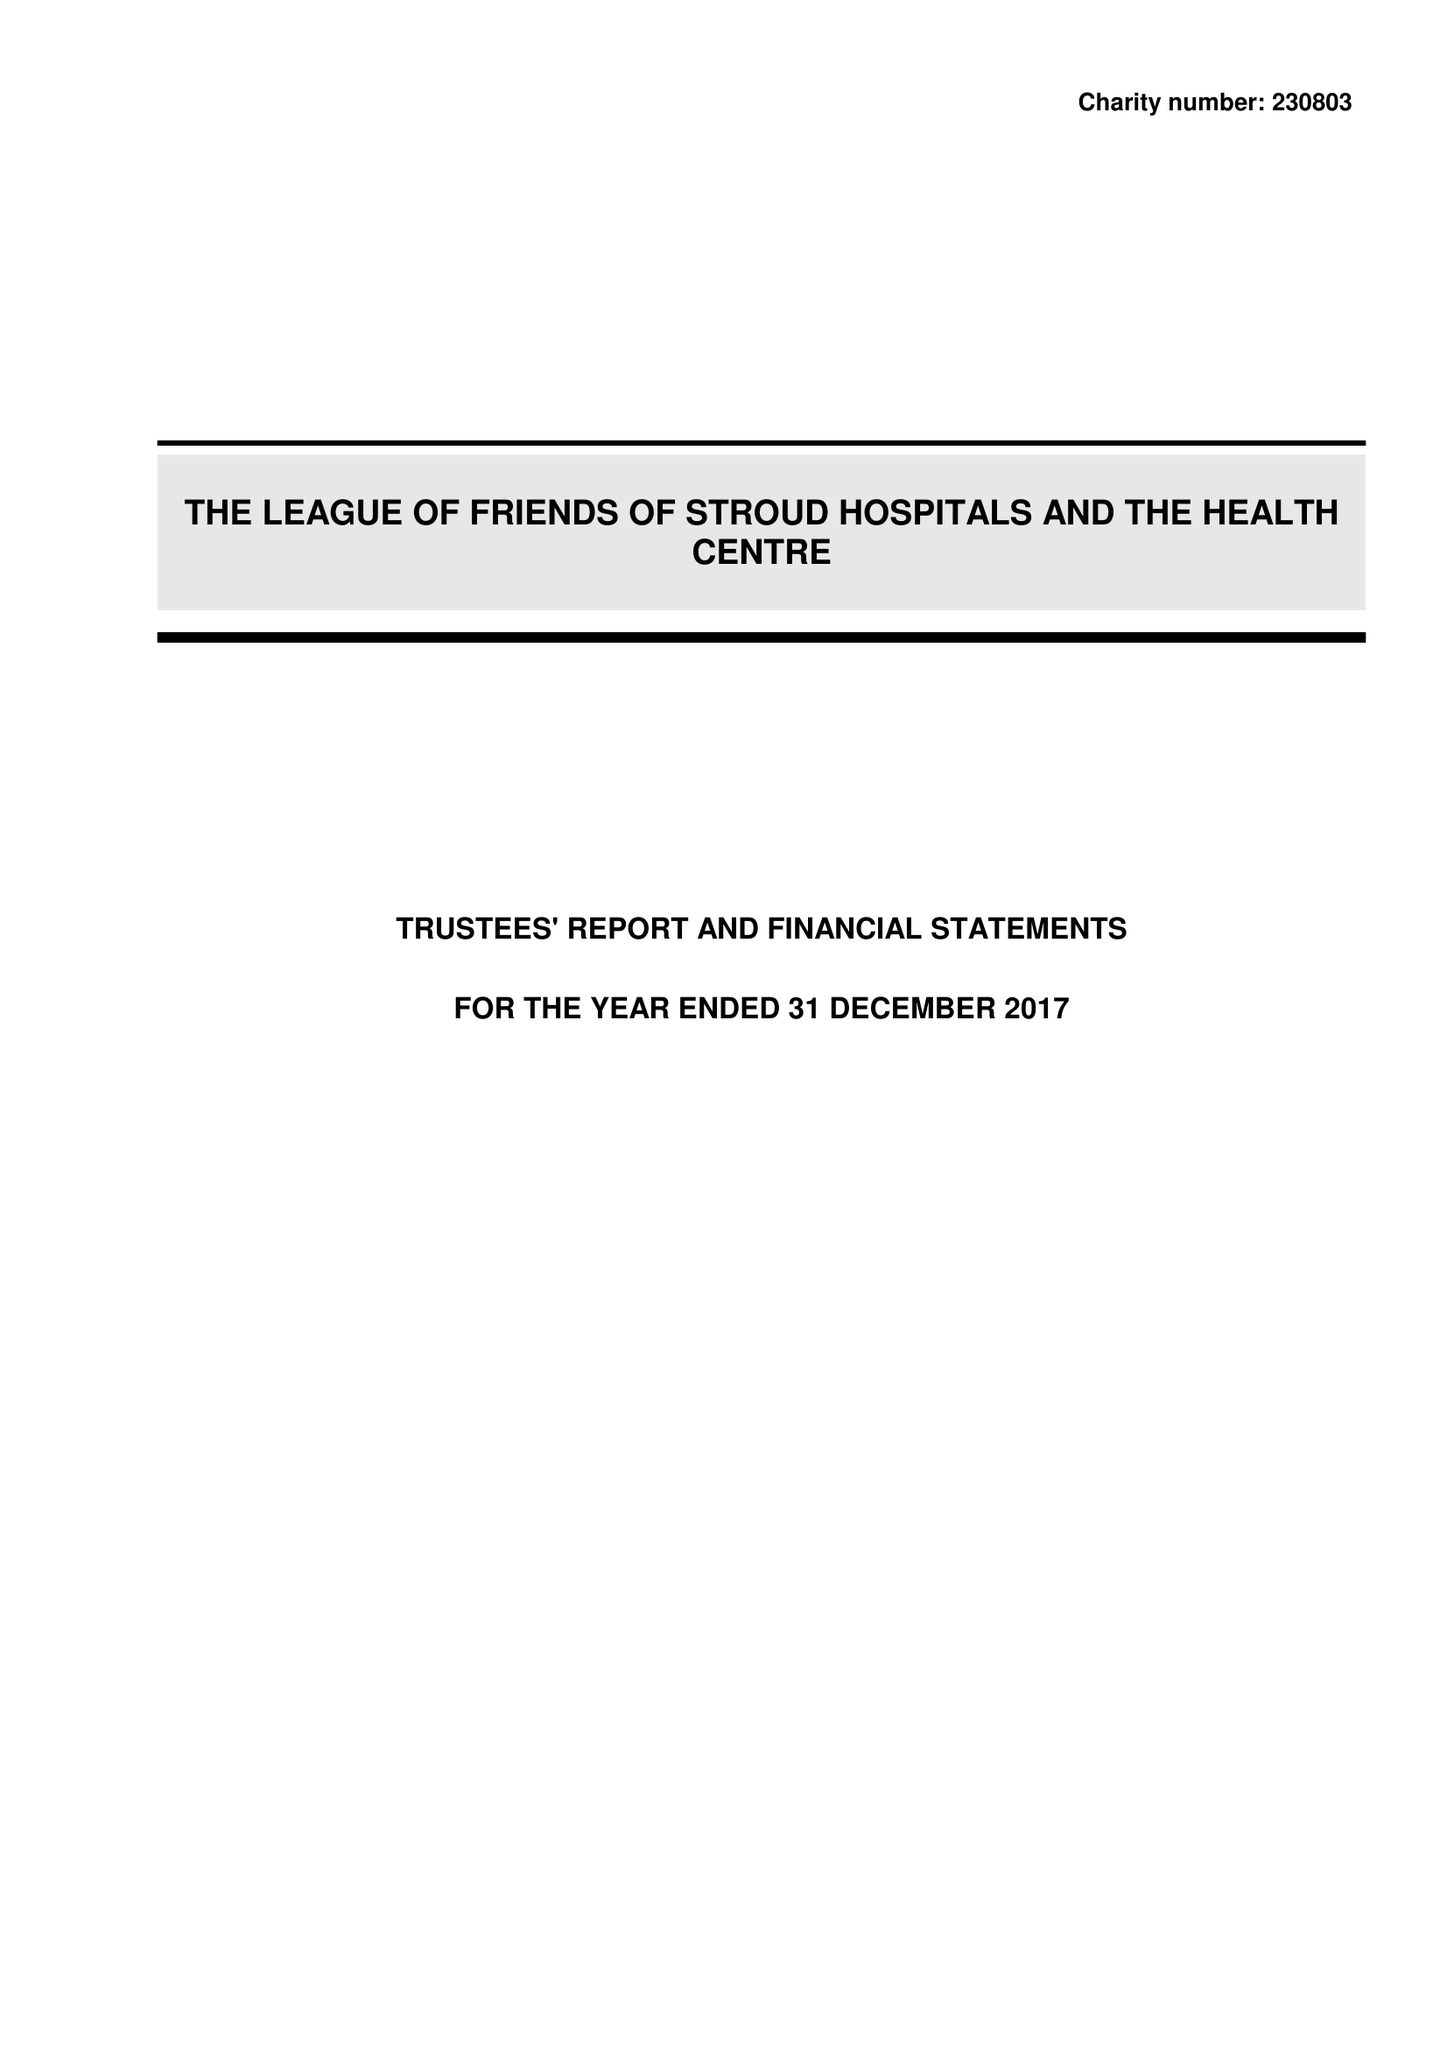What is the value for the charity_name?
Answer the question using a single word or phrase. The League Of Friends Of Stroud Hospitals and The Health Centre 